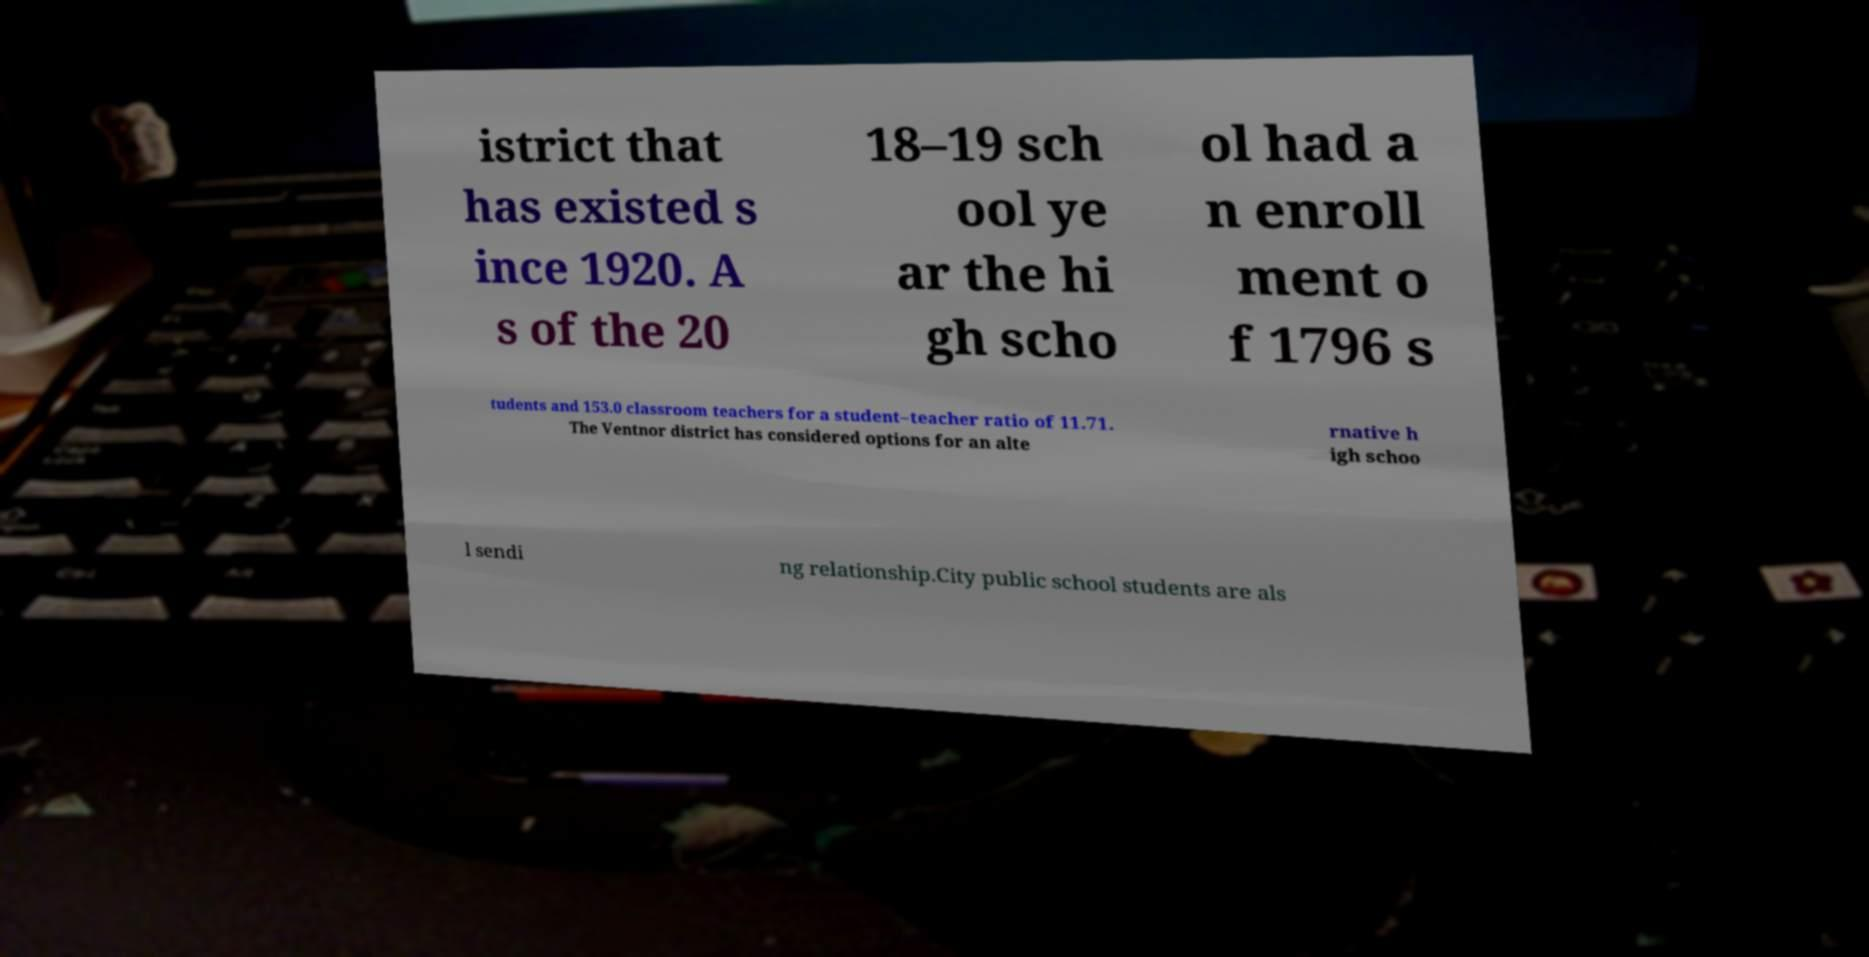Could you extract and type out the text from this image? istrict that has existed s ince 1920. A s of the 20 18–19 sch ool ye ar the hi gh scho ol had a n enroll ment o f 1796 s tudents and 153.0 classroom teachers for a student–teacher ratio of 11.71. The Ventnor district has considered options for an alte rnative h igh schoo l sendi ng relationship.City public school students are als 